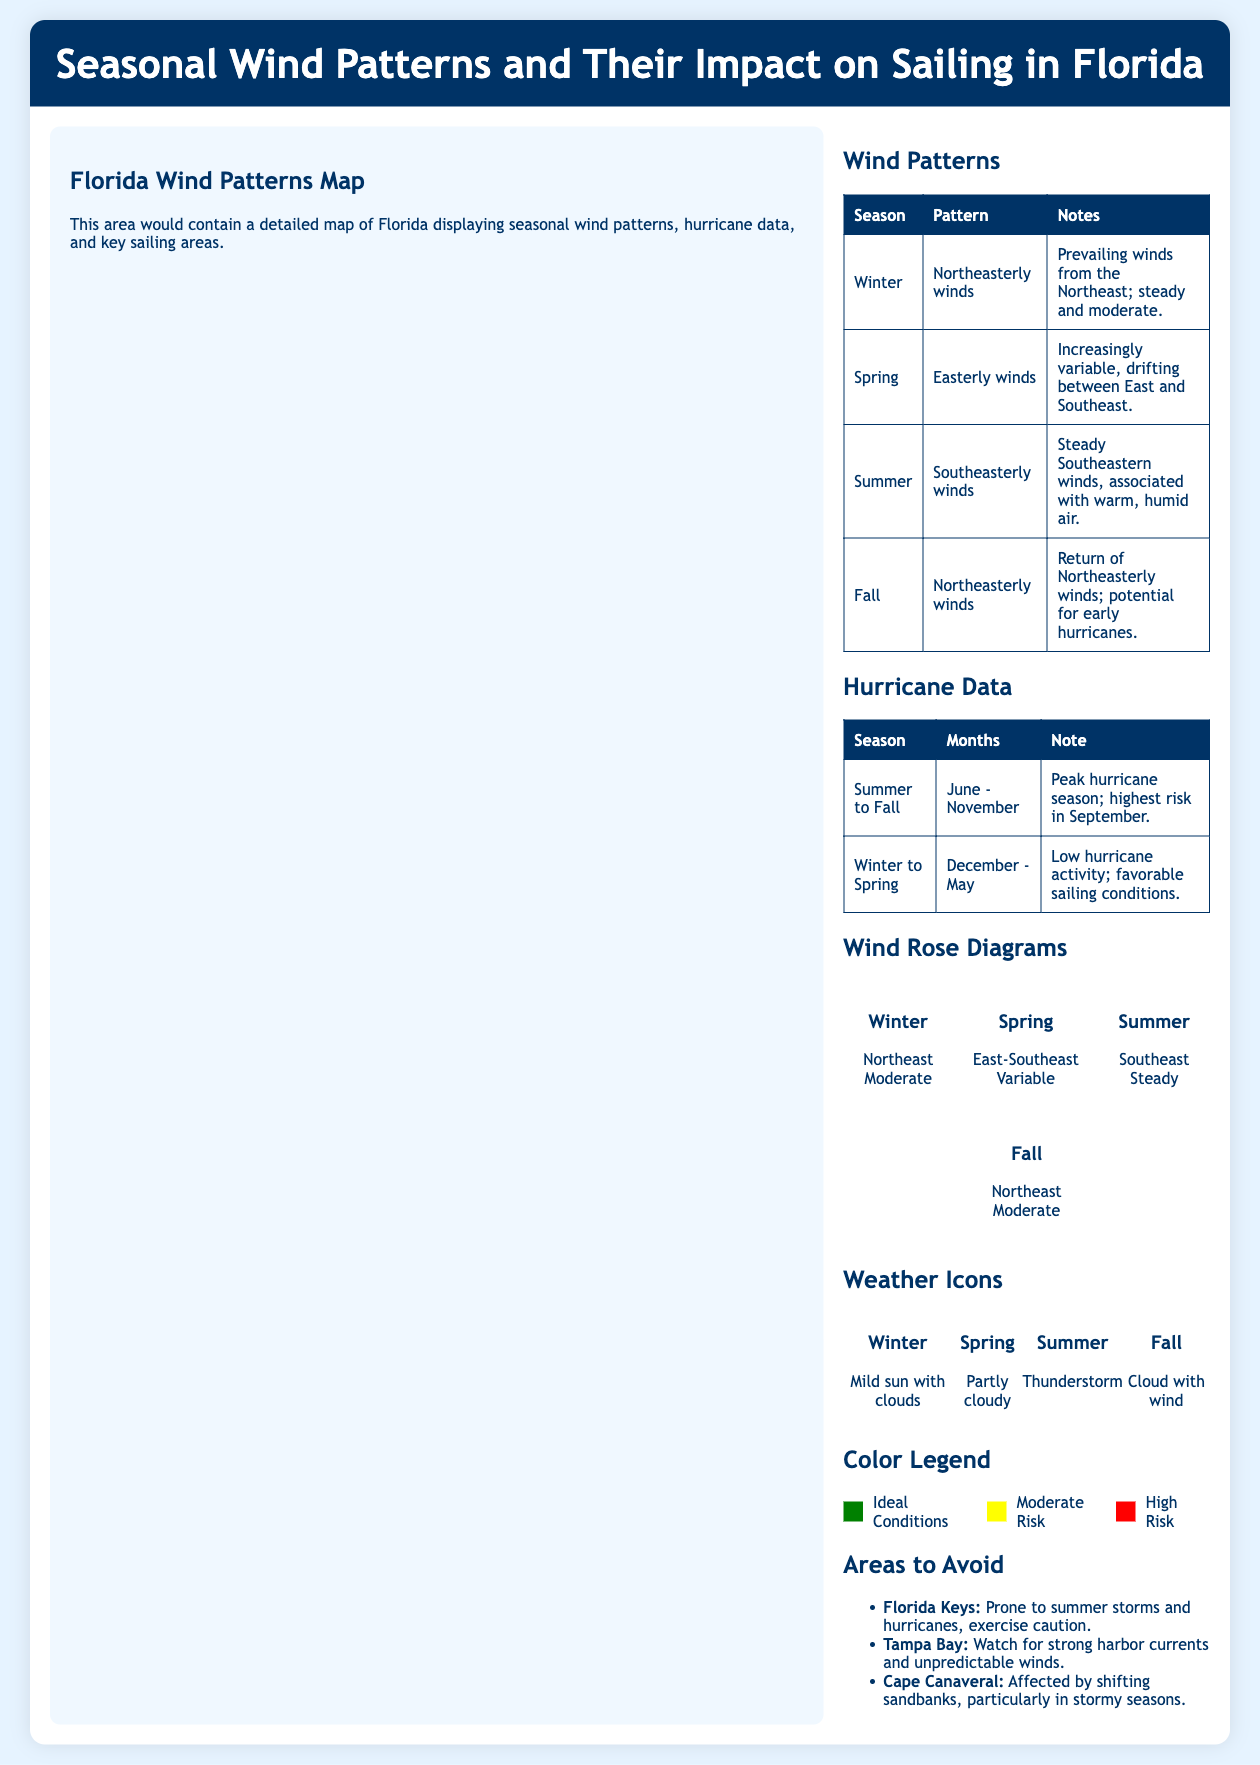What are the prevailing winds in winter? The document states that the prevailing winds in winter are from the Northeast.
Answer: Northeasterly winds What is the peak hurricane season in Florida? According to the infographic, the peak hurricane season is from June to November, with the highest risk in September.
Answer: June - November What sailing conditions are noted for winter? The notes indicate that winter has steady and moderate wind conditions.
Answer: Steady and moderate What weather icon represents summer? The infographic depicts a thunderstorm as the weather icon for summer.
Answer: Thunderstorm Which area is mentioned as prone to summer storms? The document highlights the Florida Keys as an area prone to summer storms and hurricanes.
Answer: Florida Keys How many months are considered the peak hurricane months? The peak hurricane season spans six months from June to November.
Answer: Six months What wind pattern is associated with summer? The document specifies southerly winds for summer.
Answer: Southeasterly winds What color represents ideal sailing conditions in the color legend? The legend indicates that ideal conditions are represented by the color green.
Answer: Green 